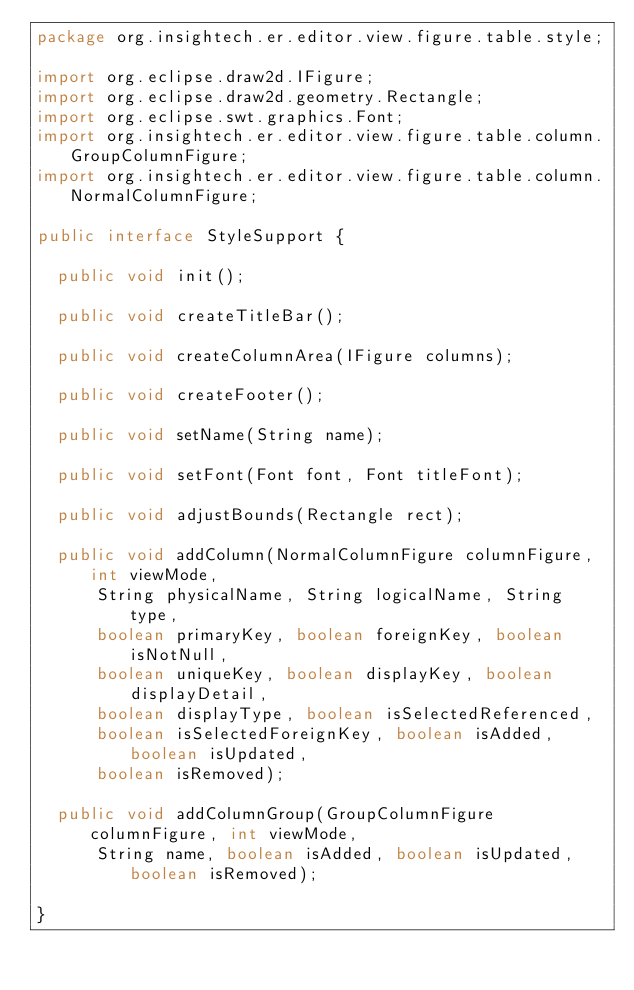Convert code to text. <code><loc_0><loc_0><loc_500><loc_500><_Java_>package org.insightech.er.editor.view.figure.table.style;

import org.eclipse.draw2d.IFigure;
import org.eclipse.draw2d.geometry.Rectangle;
import org.eclipse.swt.graphics.Font;
import org.insightech.er.editor.view.figure.table.column.GroupColumnFigure;
import org.insightech.er.editor.view.figure.table.column.NormalColumnFigure;

public interface StyleSupport {

	public void init();

	public void createTitleBar();

	public void createColumnArea(IFigure columns);

	public void createFooter();

	public void setName(String name);

	public void setFont(Font font, Font titleFont);

	public void adjustBounds(Rectangle rect);

	public void addColumn(NormalColumnFigure columnFigure, int viewMode,
			String physicalName, String logicalName, String type,
			boolean primaryKey, boolean foreignKey, boolean isNotNull,
			boolean uniqueKey, boolean displayKey, boolean displayDetail,
			boolean displayType, boolean isSelectedReferenced,
			boolean isSelectedForeignKey, boolean isAdded, boolean isUpdated,
			boolean isRemoved);

	public void addColumnGroup(GroupColumnFigure columnFigure, int viewMode,
			String name, boolean isAdded, boolean isUpdated, boolean isRemoved);

}
</code> 